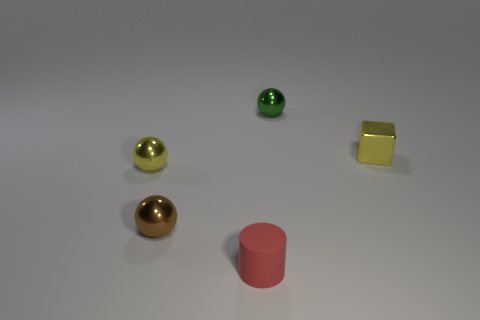Is the tiny brown shiny object the same shape as the small red object?
Provide a succinct answer. No. There is a object that is in front of the small brown thing; how big is it?
Offer a very short reply. Small. There is a yellow metal block; is its size the same as the yellow metal thing that is left of the green object?
Your response must be concise. Yes. There is a thing on the right side of the tiny metallic ball on the right side of the red cylinder; what is its color?
Your answer should be compact. Yellow. What number of other things are there of the same color as the cylinder?
Your response must be concise. 0. The block is what size?
Make the answer very short. Small. Are there more tiny metallic things that are to the left of the small rubber cylinder than metal objects that are to the left of the yellow cube?
Your answer should be very brief. No. What number of brown balls are to the left of the small yellow metallic object on the left side of the green thing?
Make the answer very short. 0. Do the yellow shiny object to the left of the brown object and the small matte thing have the same shape?
Offer a terse response. No. What is the material of the green thing that is the same shape as the brown shiny object?
Ensure brevity in your answer.  Metal. 